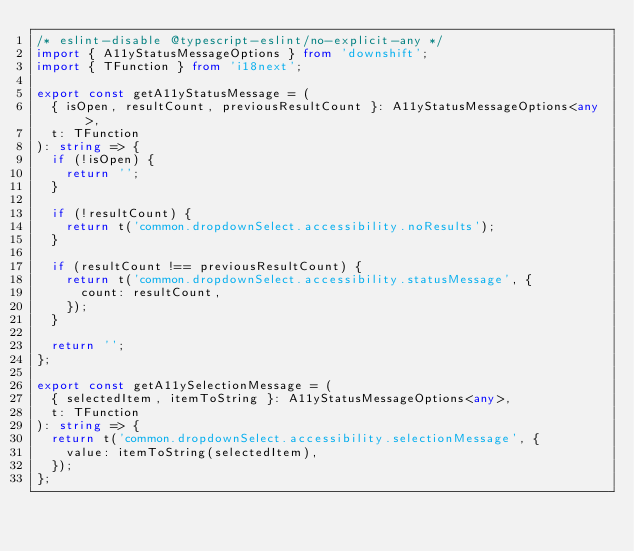<code> <loc_0><loc_0><loc_500><loc_500><_TypeScript_>/* eslint-disable @typescript-eslint/no-explicit-any */
import { A11yStatusMessageOptions } from 'downshift';
import { TFunction } from 'i18next';

export const getA11yStatusMessage = (
  { isOpen, resultCount, previousResultCount }: A11yStatusMessageOptions<any>,
  t: TFunction
): string => {
  if (!isOpen) {
    return '';
  }

  if (!resultCount) {
    return t('common.dropdownSelect.accessibility.noResults');
  }

  if (resultCount !== previousResultCount) {
    return t('common.dropdownSelect.accessibility.statusMessage', {
      count: resultCount,
    });
  }

  return '';
};

export const getA11ySelectionMessage = (
  { selectedItem, itemToString }: A11yStatusMessageOptions<any>,
  t: TFunction
): string => {
  return t('common.dropdownSelect.accessibility.selectionMessage', {
    value: itemToString(selectedItem),
  });
};
</code> 